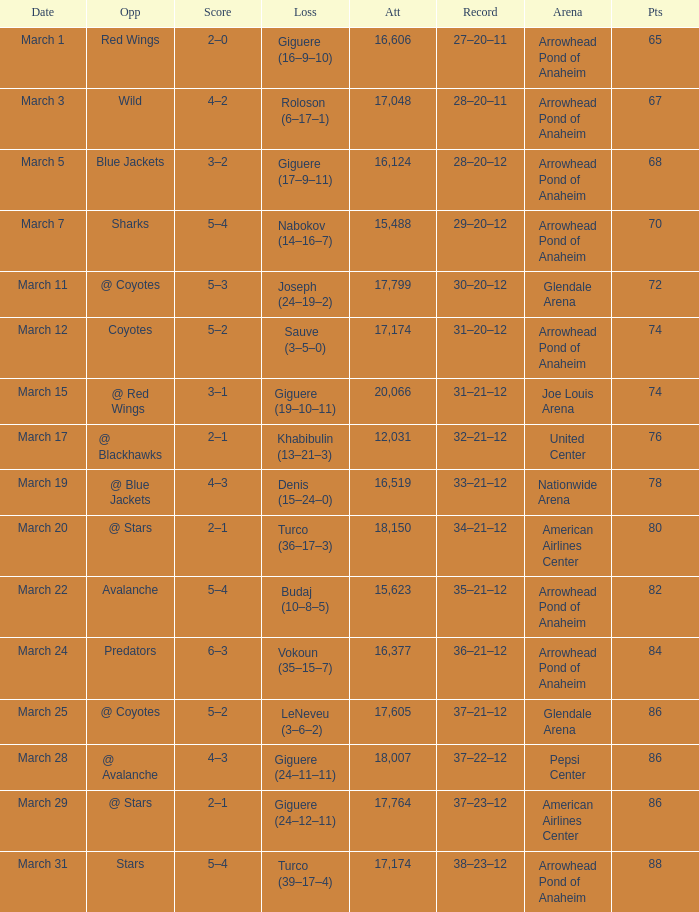How many people can attend events at joe louis arena? 20066.0. 